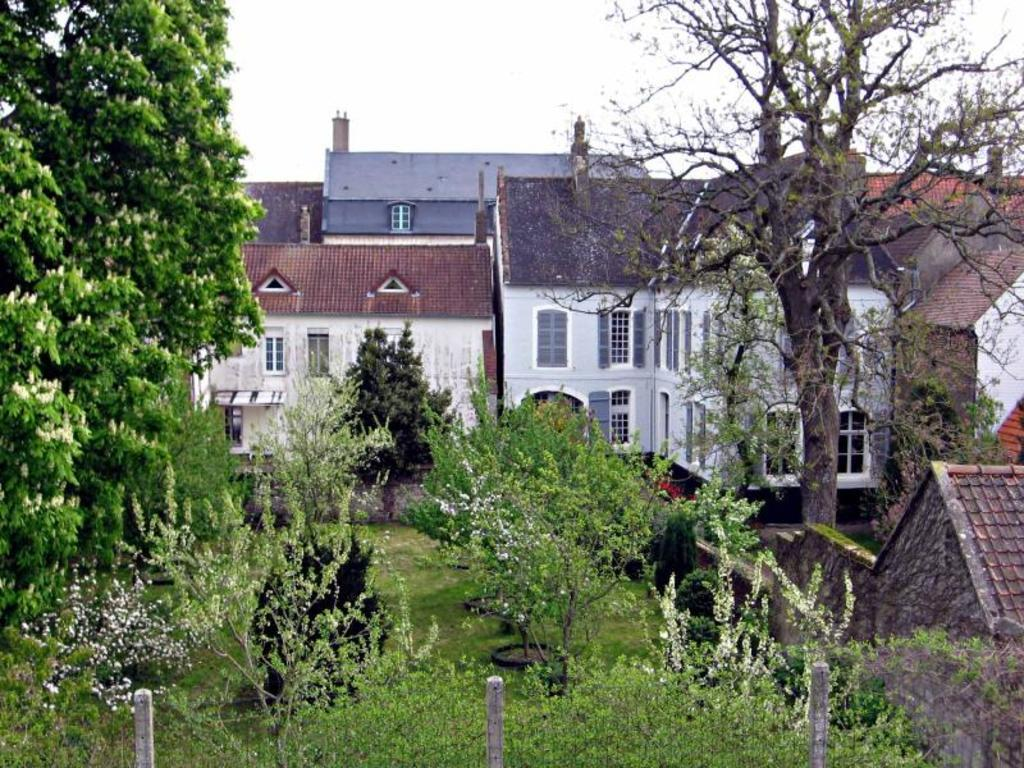What type of structures can be seen in the image? There are houses with windows in the image. What natural elements are present in the image? There are trees with branches and leaves in the image. What might be used to enclose or separate areas in the image? There appears to be a fence in the image. What type of vegetation is present in the image? Plants are present in the image. What type of religious ceremony is taking place in the image? There is no indication of a religious ceremony in the image; it features houses, trees, a fence, and plants. What is the reason for the volcano's eruption in the image? There is no volcano present in the image, so it is not possible to determine the reason for an eruption. 